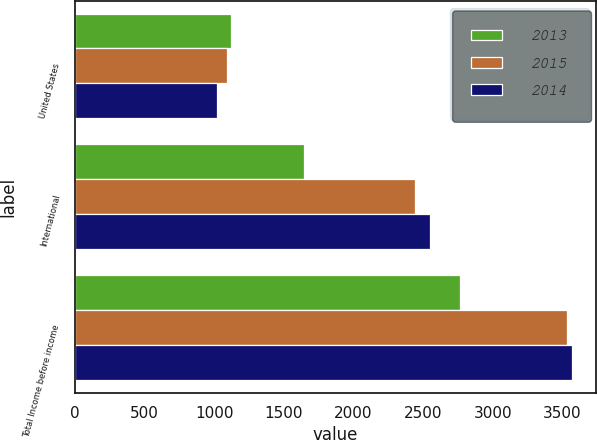Convert chart. <chart><loc_0><loc_0><loc_500><loc_500><stacked_bar_chart><ecel><fcel>United States<fcel>International<fcel>Total Income before income<nl><fcel>2013<fcel>1118<fcel>1645<fcel>2763<nl><fcel>2015<fcel>1094<fcel>2439<fcel>3533<nl><fcel>2014<fcel>1018<fcel>2547<fcel>3565<nl></chart> 